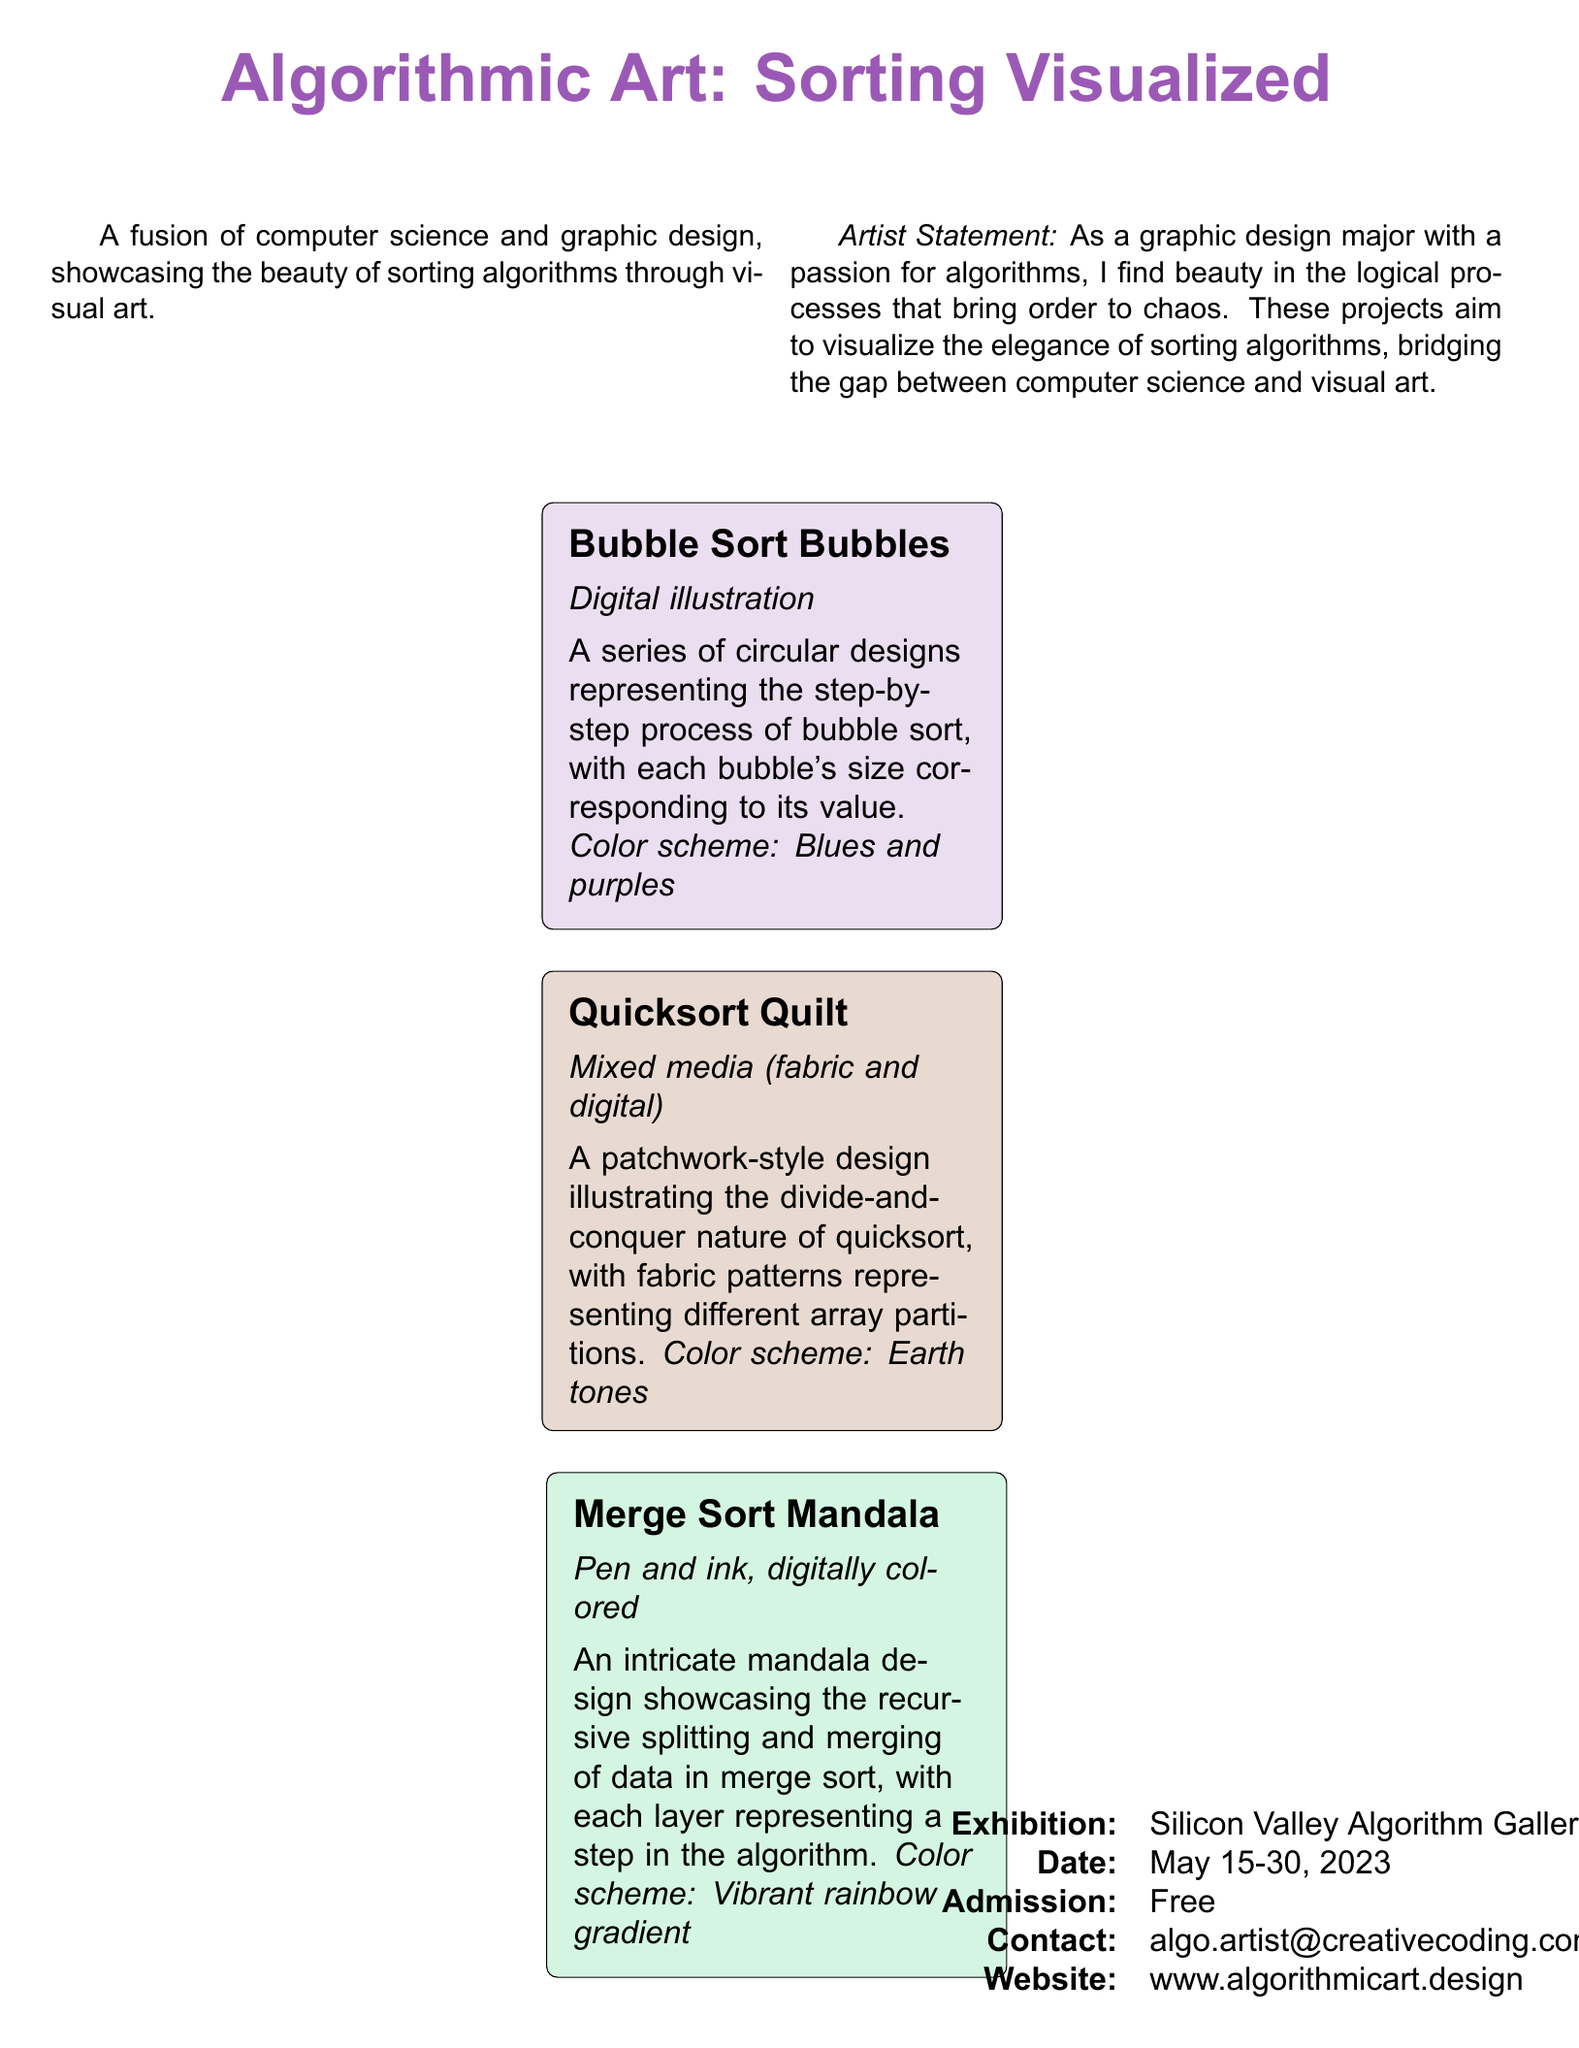What is the title of the exhibit? The title of the exhibit is prominently displayed at the beginning of the document.
Answer: Algorithmic Art: Sorting Visualized Who is the artist? The artist is introduced in the artist statement section of the document.
Answer: Unknown What are the color tones used in the "Quicksort Quilt"? The color scheme for the "Quicksort Quilt" is specified in the project description.
Answer: Earth tones When is the exhibition scheduled? The document includes a specific date range for the exhibition.
Answer: May 15-30, 2023 What technique is used in the "Merge Sort Mandala"? The technique for the "Merge Sort Mandala" is described in the project details.
Answer: Pen and ink, digitally colored Which project uses a digital illustration method? The project method is outlined in the descriptions of the artworks.
Answer: Bubble Sort Bubbles What type of design is "Bubble Sort Bubbles"? The type of design for "Bubble Sort Bubbles" is mentioned within its description.
Answer: Digital illustration Where is the exhibition held? The location of the exhibition is stated in the document.
Answer: Silicon Valley Algorithm Gallery 